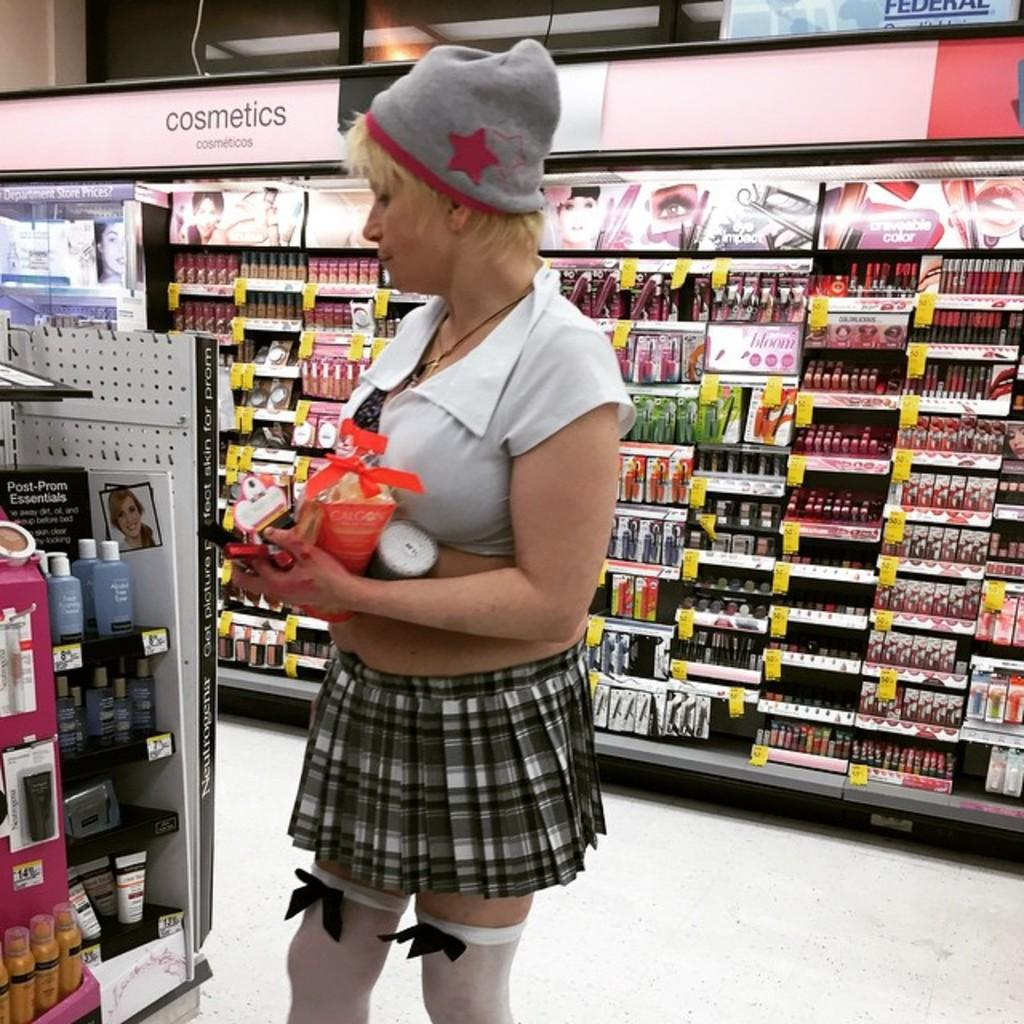<image>
Share a concise interpretation of the image provided. A woman is in the cosmetics isle of the drugstore. 